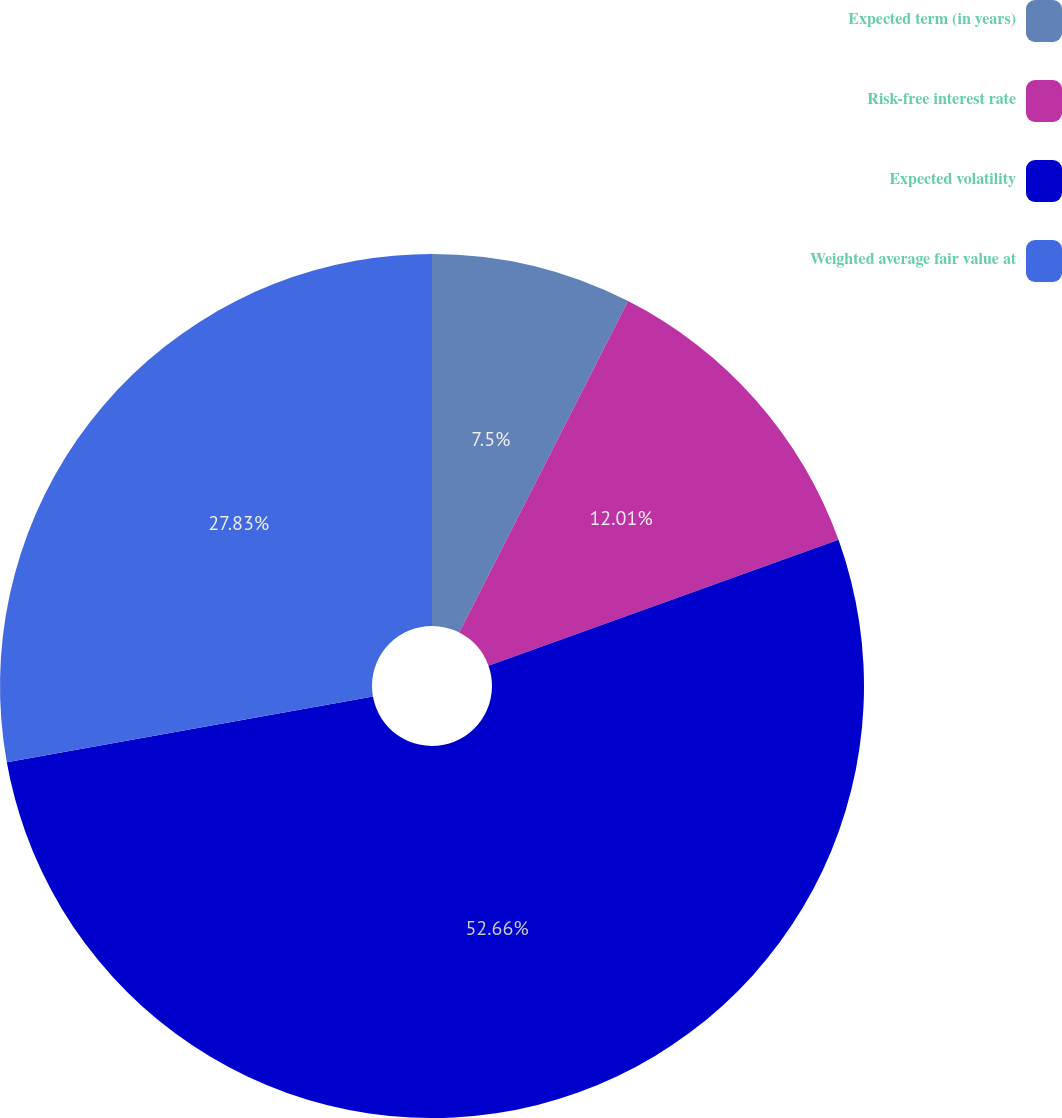Convert chart to OTSL. <chart><loc_0><loc_0><loc_500><loc_500><pie_chart><fcel>Expected term (in years)<fcel>Risk-free interest rate<fcel>Expected volatility<fcel>Weighted average fair value at<nl><fcel>7.5%<fcel>12.01%<fcel>52.67%<fcel>27.83%<nl></chart> 